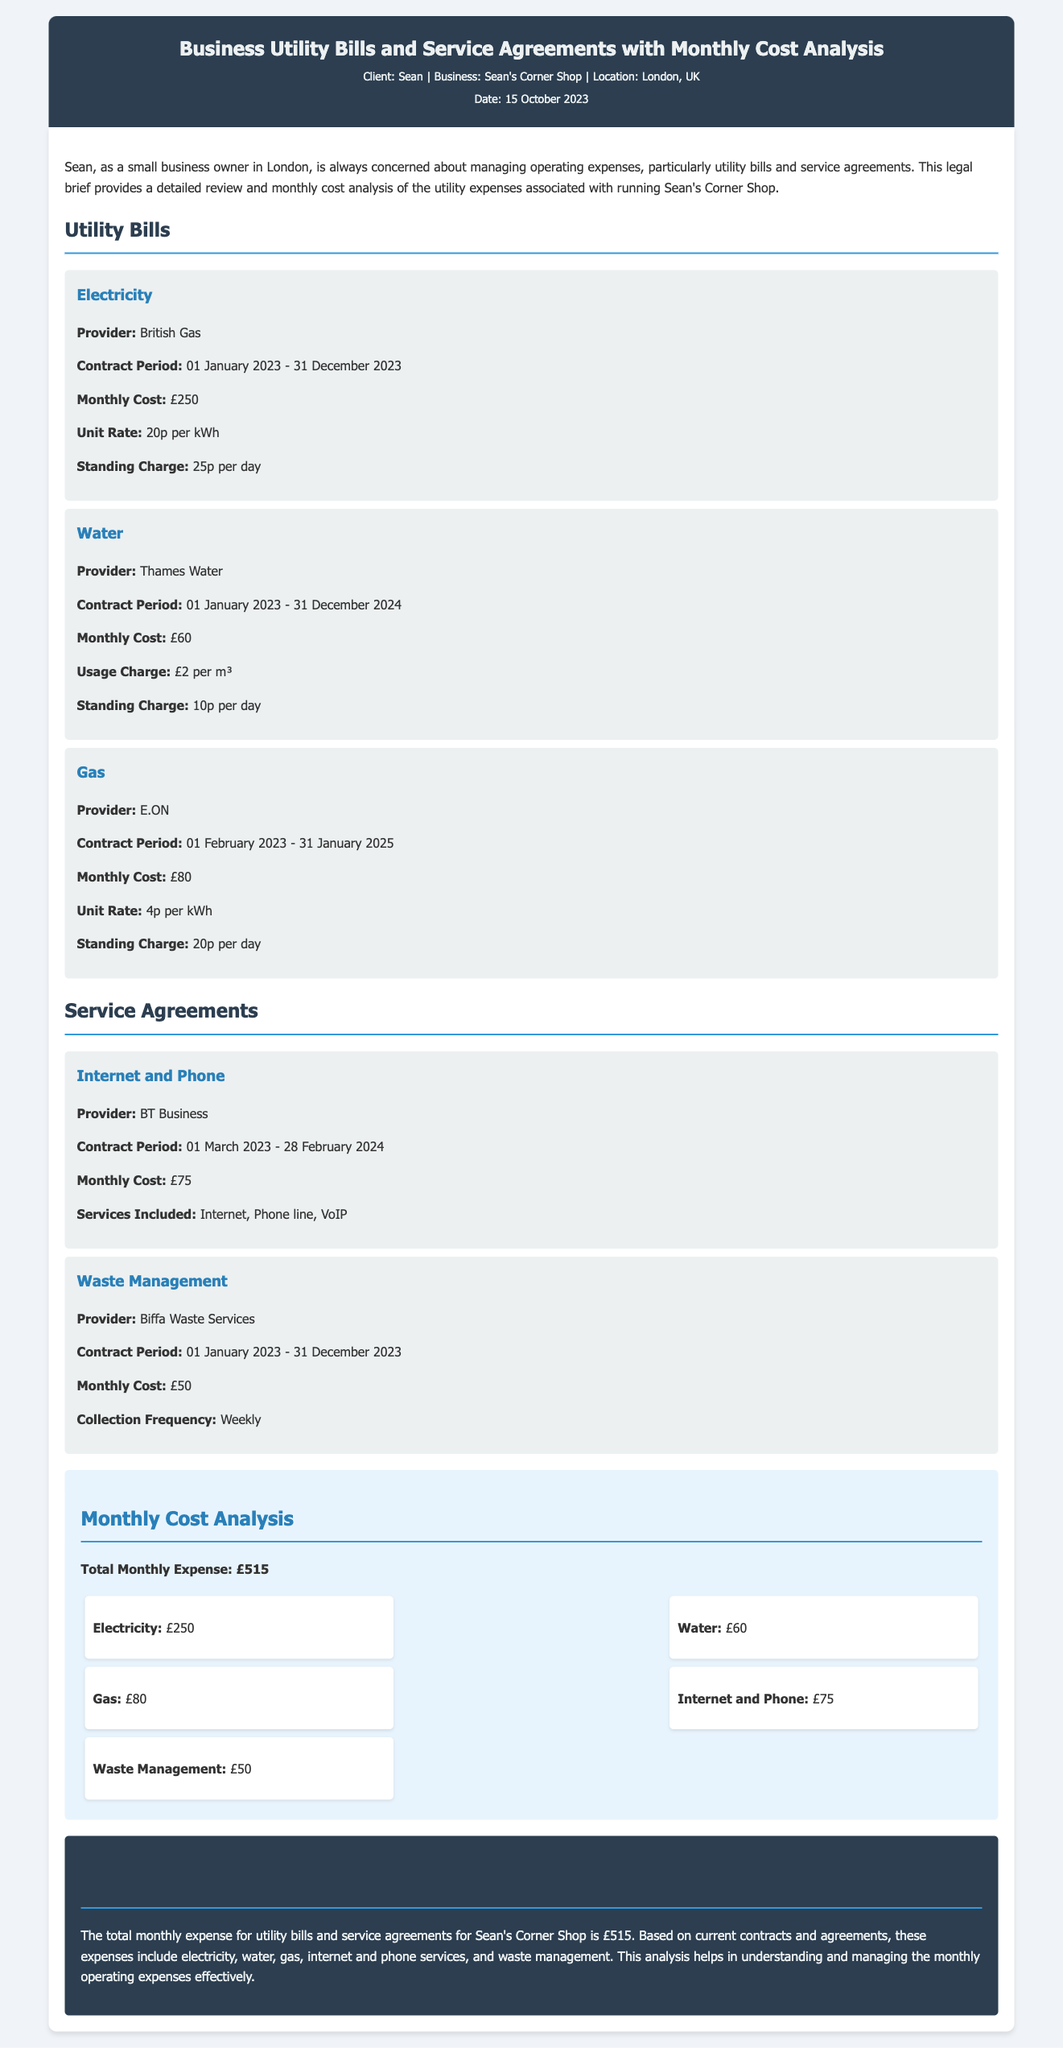What is the total monthly expense? The total monthly expense is summarized at the end of the cost analysis section, which includes all utility and service fees.
Answer: £515 Who is the electricity provider? The document specifies the provider of electricity under the utility bills section.
Answer: British Gas What is the monthly cost for water? The water monthly cost is detailed in the utility bills section.
Answer: £60 What is the service included with the Internet and Phone agreement? The services included are listed under the Internet and Phone service agreement.
Answer: Internet, Phone line, VoIP What is the standing charge for gas? The standing charge for gas is indicated in the gas utility item.
Answer: 20p per day How long is the contract period for water services? The contract period for water services is noted in the water utility item.
Answer: 01 January 2023 - 31 December 2024 What is the collection frequency for waste management? The collection frequency for waste management is provided in the waste management service item.
Answer: Weekly What is the unit rate for electricity? The unit rate for electricity is specified under the electricity utility item.
Answer: 20p per kWh Which month does the Internet and Phone contract begin? The start month for the Internet and Phone contract is mentioned in its service item.
Answer: March 